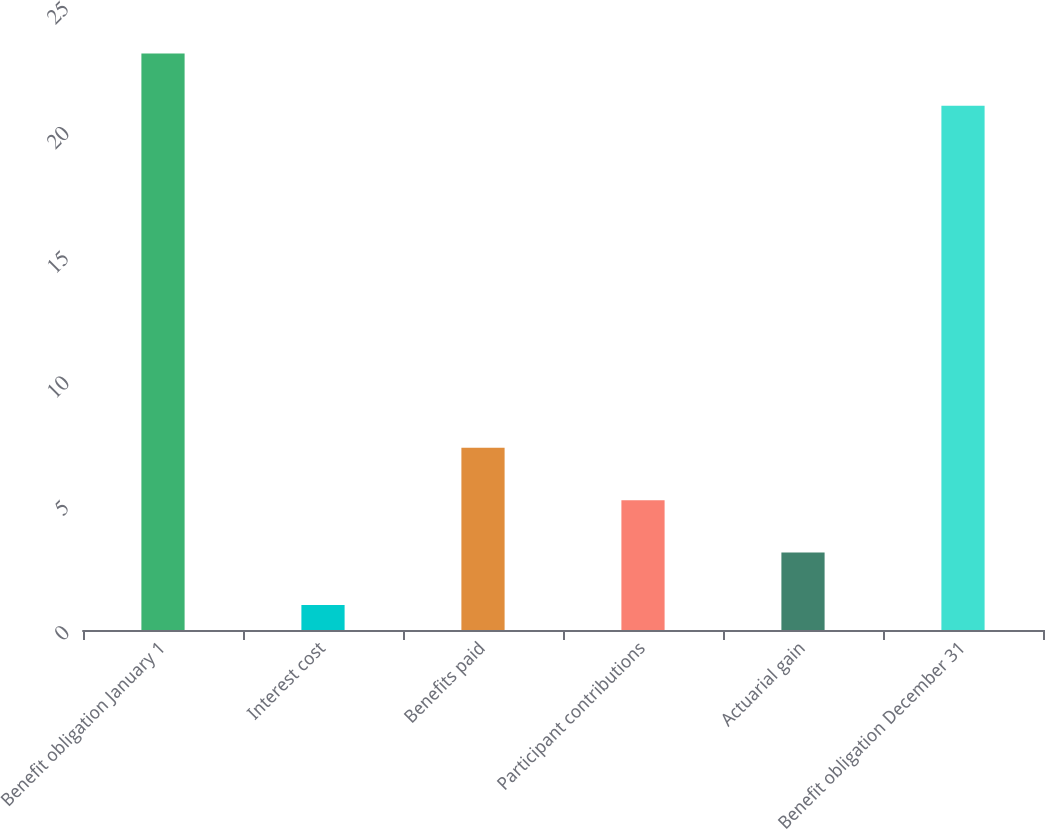Convert chart to OTSL. <chart><loc_0><loc_0><loc_500><loc_500><bar_chart><fcel>Benefit obligation January 1<fcel>Interest cost<fcel>Benefits paid<fcel>Participant contributions<fcel>Actuarial gain<fcel>Benefit obligation December 31<nl><fcel>23.1<fcel>1<fcel>7.3<fcel>5.2<fcel>3.1<fcel>21<nl></chart> 